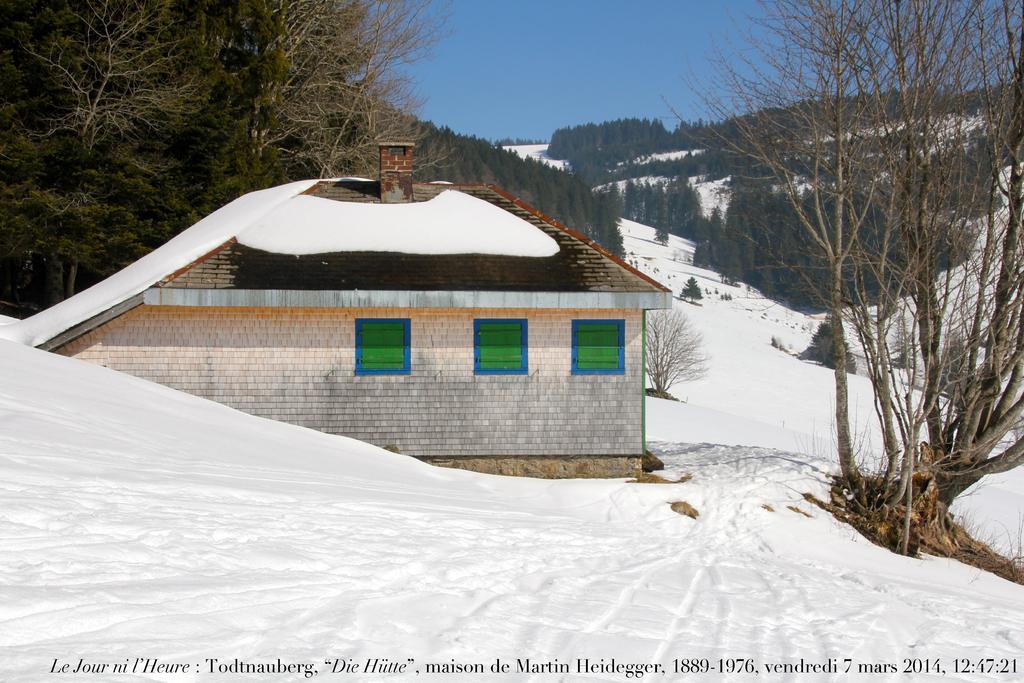Please provide a concise description of this image. In the image there are buildings in the front followed by trees behind it all over the place on snow land and above its sky. 